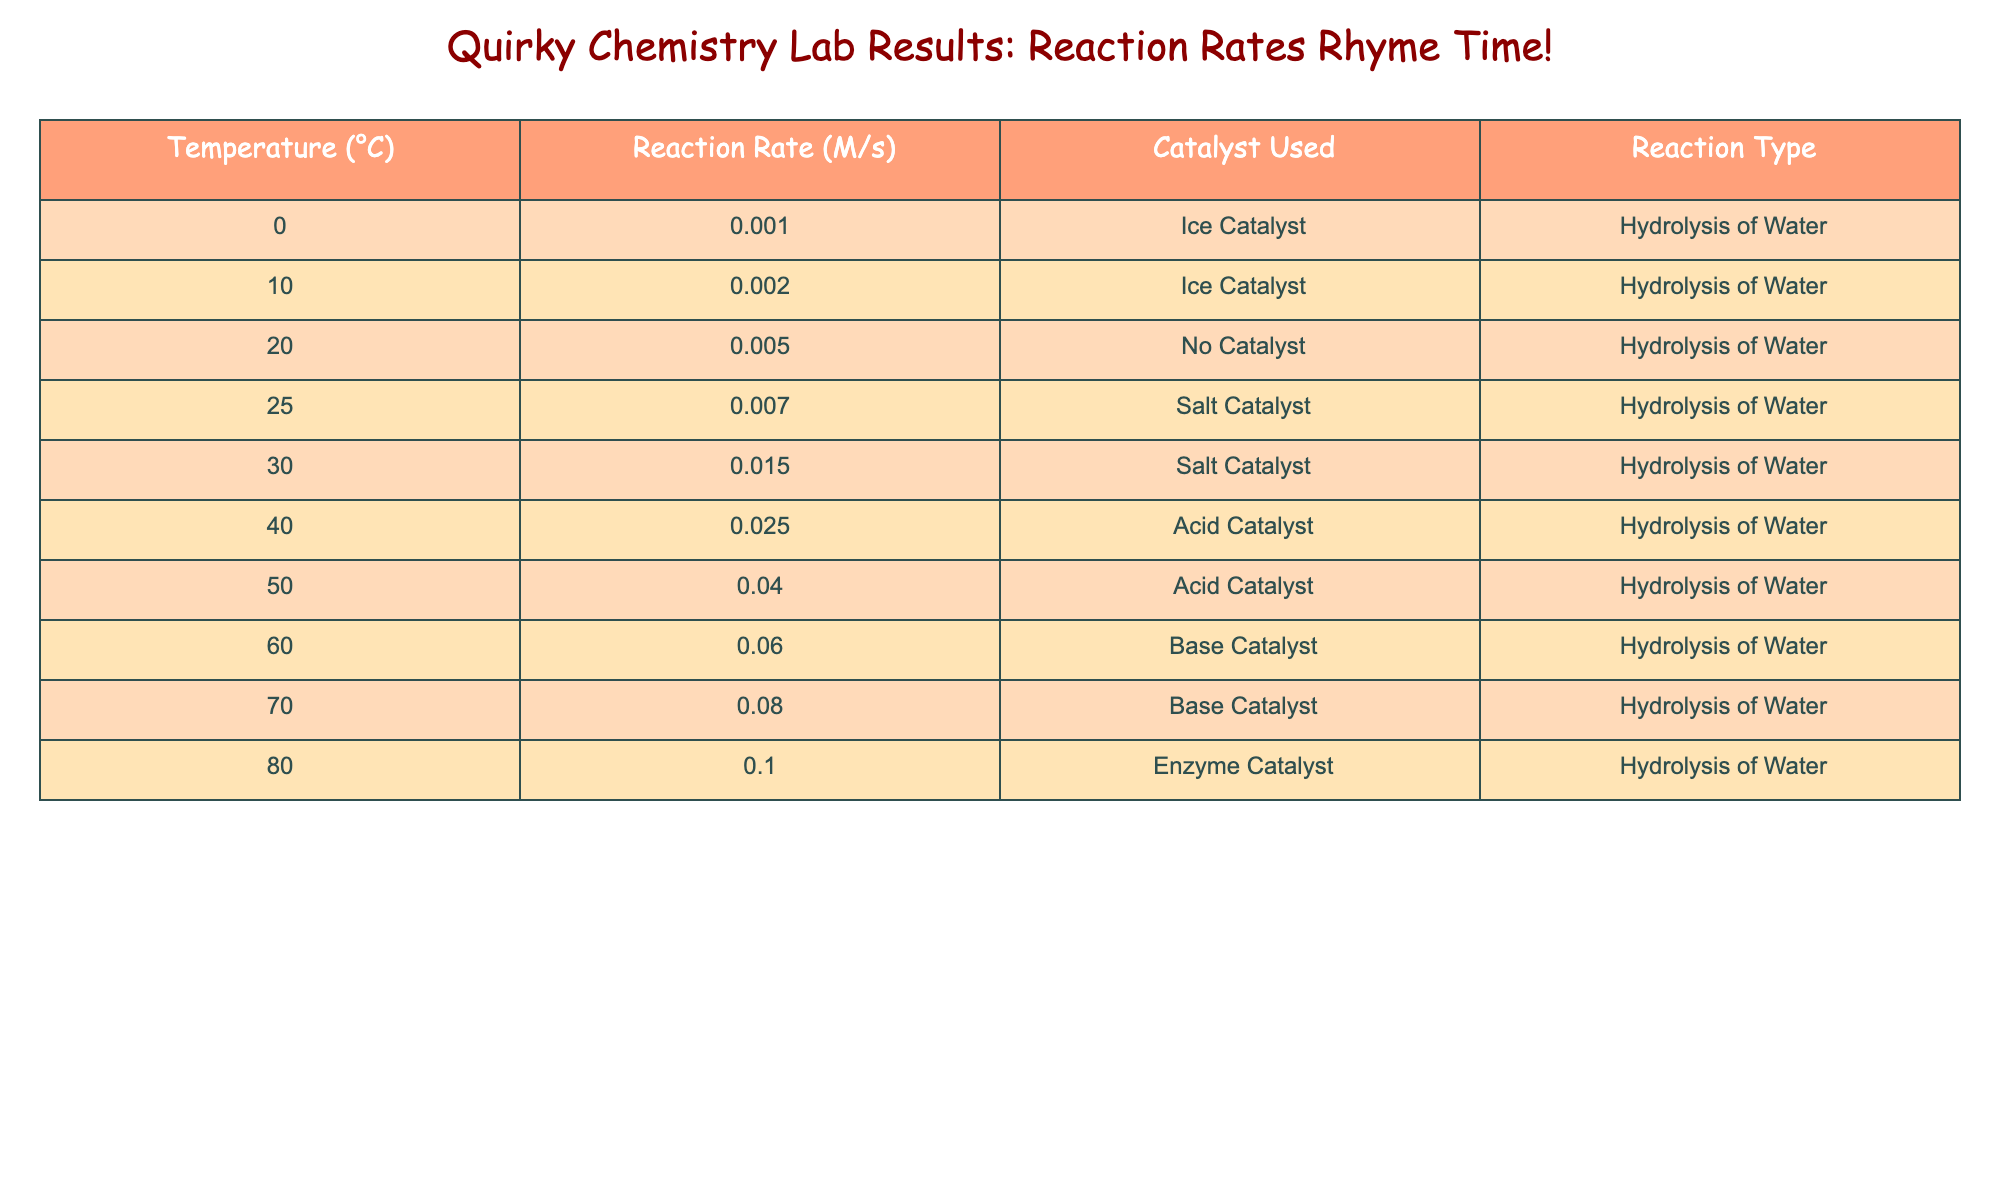What is the reaction rate at 50°C? From the table, I can find the row where the temperature is 50°C. The reaction rate listed for that temperature is 0.040 M/s.
Answer: 0.040 M/s What catalyst was used at 80°C? Looking at the row where the temperature is 80°C, I see that the catalyst used is the "Enzyme Catalyst."
Answer: Enzyme Catalyst What is the highest reaction rate observed in the table? To find this, I check all the reaction rates listed. The maximum value is 0.100 M/s at 80°C.
Answer: 0.100 M/s What is the average reaction rate for temperatures below 30°C? I gather the reaction rates for temperatures 0°C, 10°C, and 20°C, which are 0.001, 0.002, and 0.005 M/s. The sum is 0.001 + 0.002 + 0.005 = 0.008. Since there are 3 rates, I divide 0.008 by 3, resulting in approximately 0.00267 M/s.
Answer: 0.00267 M/s Is the reaction rate at 40°C higher than at 25°C? The reaction rate at 40°C is 0.025 M/s and at 25°C is 0.007 M/s. Since 0.025 is greater than 0.007, the answer is yes.
Answer: Yes What is the difference in reaction rates between 30°C and 60°C? The reaction rate at 30°C is 0.015 M/s and at 60°C is 0.060 M/s. To find the difference, I subtract 0.015 from 0.060, which is 0.060 - 0.015 = 0.045 M/s.
Answer: 0.045 M/s How many reaction types are listed in the table? The table shows only one reaction type, "Hydrolysis of Water," for all entries. Therefore, there is just one type.
Answer: 1 What is the reaction rate at the highest temperature, which is 70°C? By locating the row for 70°C in the table, I read the reaction rate, which is 0.080 M/s.
Answer: 0.080 M/s Is a Salt Catalyst used at any temperature below 30°C? Checking the entries with temperatures below 30°C, I see no Salt Catalyst used; the only catalysts below that temperature are "Ice Catalyst" and "No Catalyst."
Answer: No 